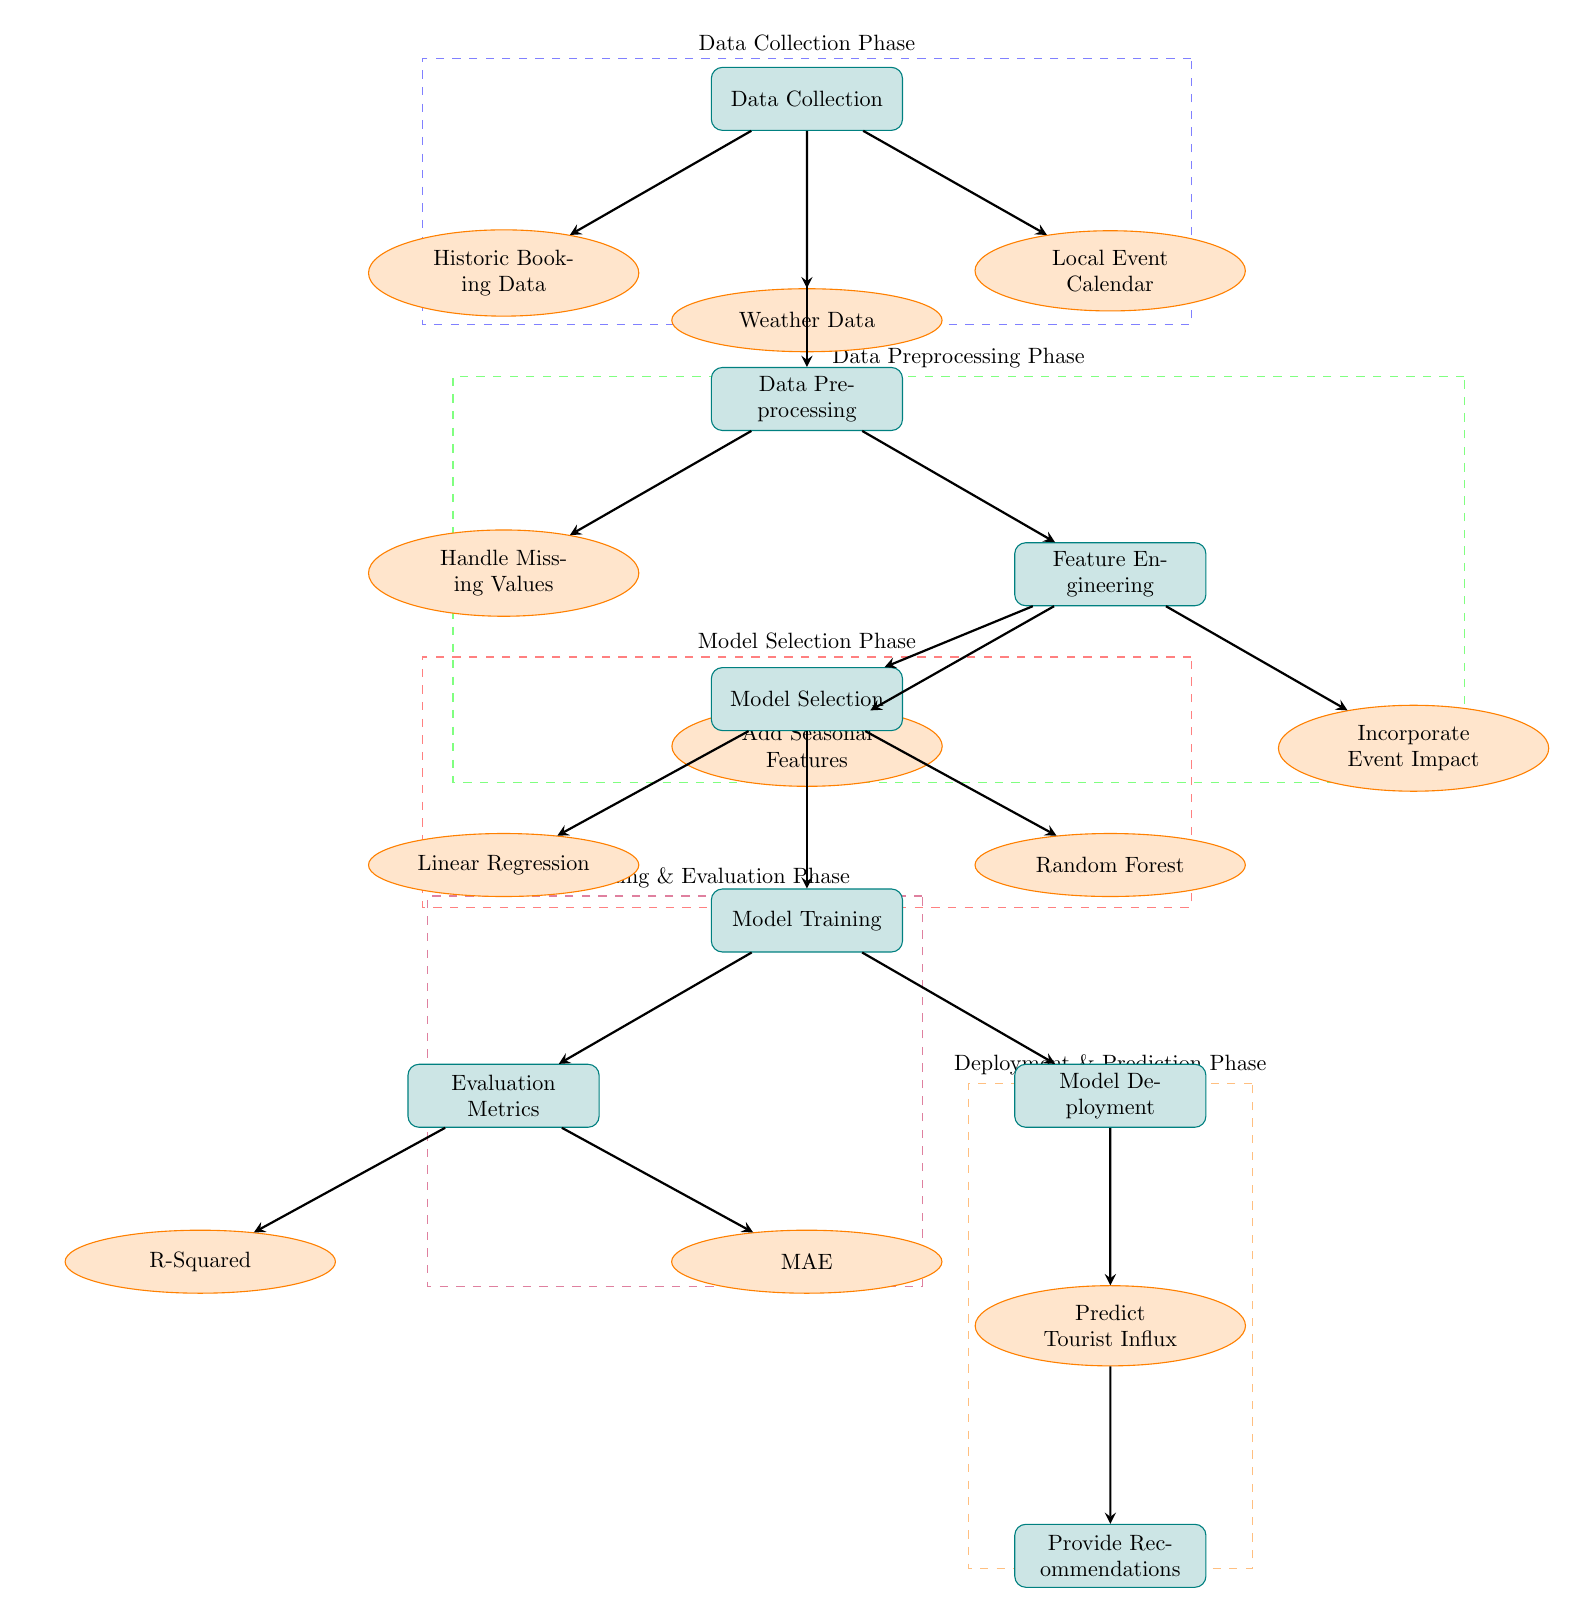What is the first step in the process? The first step in the process is labeled as 'Data Collection', which is represented at the top of the diagram. This step collects data required for the subsequent analysis.
Answer: Data Collection How many data sources are involved in the data collection phase? In the data collection phase, there are three data sources indicated: 'Historic Booking Data', 'Weather Data', and 'Local Event Calendar'. These sources feed into the data collection process.
Answer: Three What is the output of the 'Model Training' process? The 'Model Training' process leads to 'Model Deployment', indicating that the output is the deployment of the trained model, which will be used for predictions.
Answer: Model Deployment What technique is used in the model selection phase besides linear regression? In the model selection phase, besides linear regression, the other technique is 'Random Forest', as indicated alongside linear regression in the diagram.
Answer: Random Forest Which phase includes the handling of missing values? The 'Data Preprocessing Phase' includes the handling of missing values, specifically labeled as 'Handle Missing Values' within that phase.
Answer: Data Preprocessing Phase What evaluation metric is represented along with R-squared? Along with R-squared in the 'Evaluation Metrics' process, the other evaluation metric represented is 'MAE', which stands for Mean Absolute Error.
Answer: MAE Which two features are added during feature engineering? During feature engineering, two features are added: 'Add Seasonal Features' and 'Incorporate Event Impact', as indicated in the flow from the feature engineering process.
Answer: Add Seasonal Features, Incorporate Event Impact What is the last process in the diagram? The last process in the diagram is labeled as 'Provide Recommendations', which follows after 'Predict Tourist Influx', indicating the final output of the analysis.
Answer: Provide Recommendations How many phases are there in the entire diagram? There are five phases in the entire diagram, including 'Data Collection Phase', 'Data Preprocessing Phase', 'Model Selection Phase', 'Model Training & Evaluation Phase', and 'Deployment & Prediction Phase'.
Answer: Five 